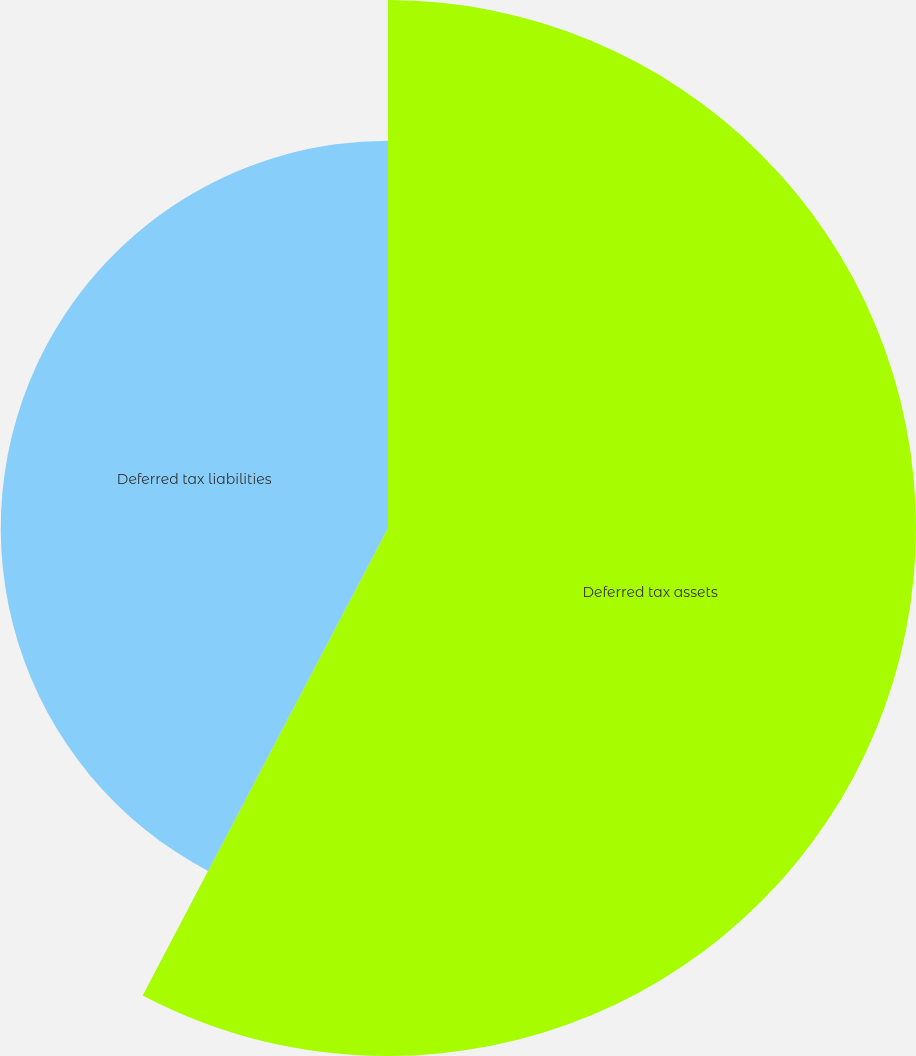Convert chart. <chart><loc_0><loc_0><loc_500><loc_500><pie_chart><fcel>Deferred tax assets<fcel>Deferred tax liabilities<nl><fcel>57.69%<fcel>42.31%<nl></chart> 